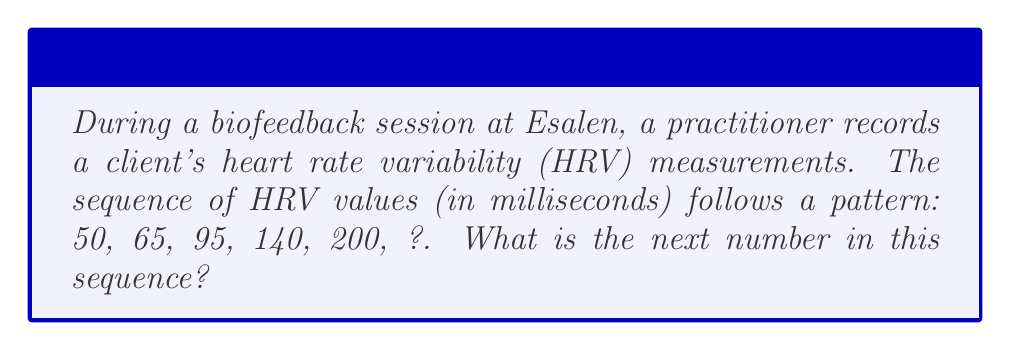Teach me how to tackle this problem. To find the next number in the sequence, we need to identify the pattern:

1. Calculate the differences between consecutive terms:
   $65 - 50 = 15$
   $95 - 65 = 30$
   $140 - 95 = 45$
   $200 - 140 = 60$

2. Observe that the differences form an arithmetic sequence:
   $15, 30, 45, 60$

3. The common difference in this arithmetic sequence is:
   $30 - 15 = 45 - 30 = 60 - 45 = 15$

4. Therefore, the next difference in the sequence should be:
   $60 + 15 = 75$

5. To find the next term in the original sequence, add this difference to the last known term:
   $200 + 75 = 275$

Thus, the next number in the HRV measurement sequence is 275 milliseconds.
Answer: 275 